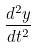<formula> <loc_0><loc_0><loc_500><loc_500>\frac { d ^ { 2 } y } { d t ^ { 2 } }</formula> 